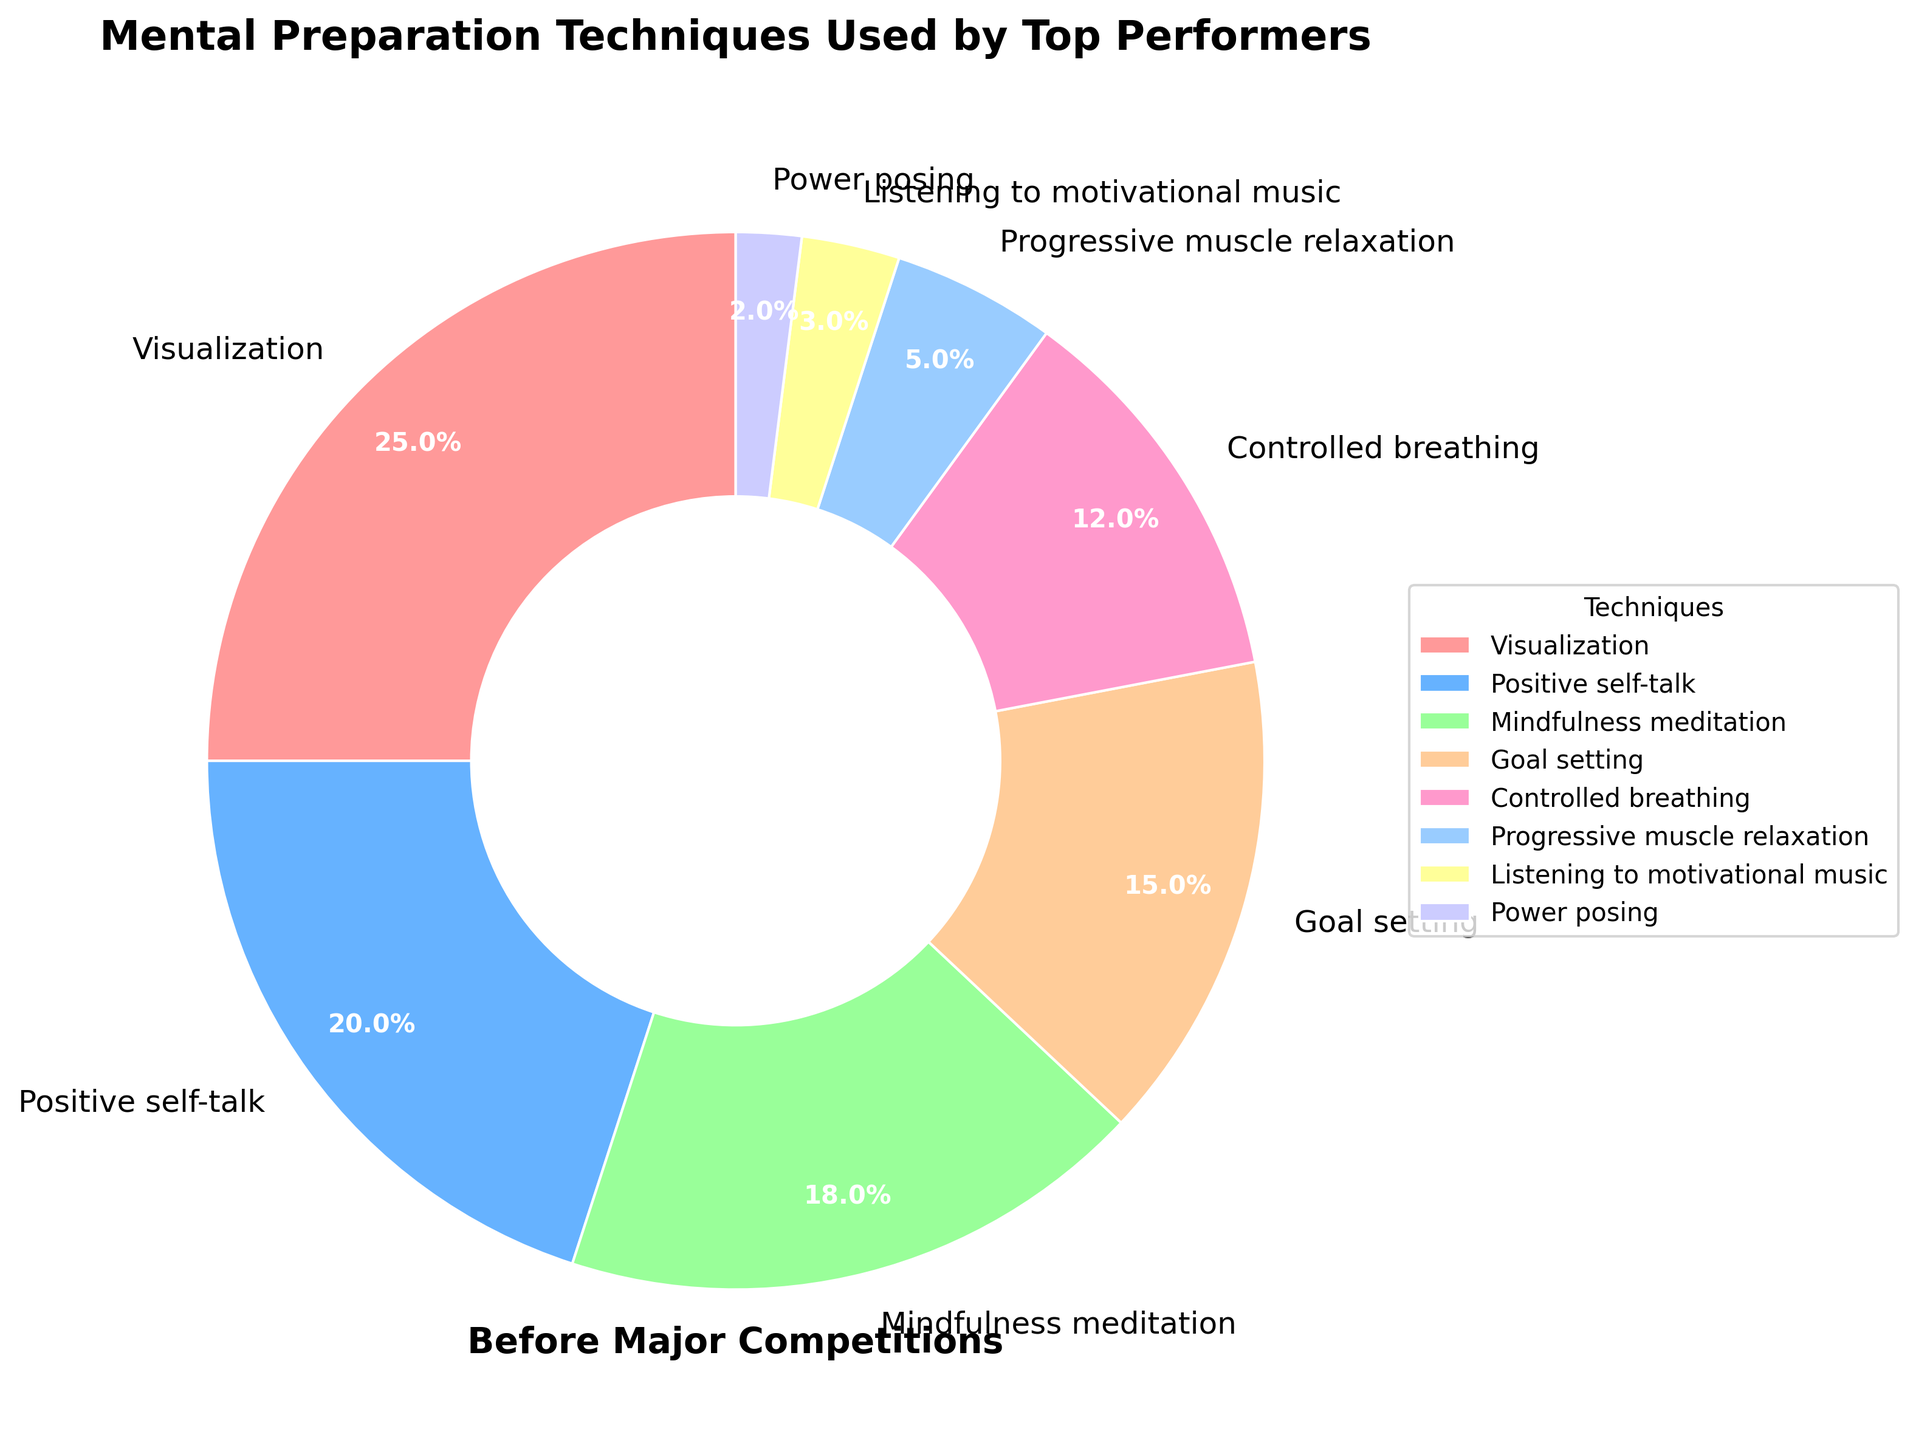What is the most commonly used mental preparation technique? The pie chart shows the percentages of different mental preparation techniques. The largest section of the chart represents "Visualization" with 25%. Therefore, "Visualization" is the most commonly used technique.
Answer: Visualization Which technique is more popular: Mindfulness meditation or Controlled breathing? The pie chart shows that "Mindfulness meditation" has a percentage of 18%, while "Controlled breathing" has a percentage of 12%. Therefore, "Mindfulness meditation" is more popular.
Answer: Mindfulness meditation What is the combined percentage of Positive self-talk and Goal setting? To find the combined percentage, add the percentages of "Positive self-talk" (20%) and "Goal setting" (15%): 20% + 15% = 35%.
Answer: 35% Which technique is least used by top performers? The smallest section in the pie chart represents "Power posing" with 2%. Therefore, "Power posing" is the least used technique by top performers.
Answer: Power posing How does the use of Listen to motivational music compare to Progressive muscle relaxation? According to the pie chart, "Listening to motivational music" has a percentage of 3%, while "Progressive muscle relaxation" has 5%. Hence, "Progressive muscle relaxation" is used more frequently than "Listening to motivational music".
Answer: Progressive muscle relaxation What fraction of the techniques have a percentage of 15% or higher? Techniques with percentages of 15% or higher are: "Visualization" (25%), "Positive self-talk" (20%), and "Goal setting" (15%). There are 8 techniques in total. Therefore, the fraction is 3/8.
Answer: 3/8 Is the percentage for Visualization greater than the combined percentage for Power posing and Listening to motivational music? The percentage for "Visualization" is 25%. The combined percentage for "Power posing" (2%) and "Listening to motivational music" (3%) is: 2% + 3% = 5%. Since 25% is greater than 5%, the percentage for "Visualization" is indeed greater.
Answer: Yes Are there any techniques that make up less than 5% of the chart? The pie chart shows that "Power posing" makes up 2% and "Listening to motivational music" makes up 3%. Both are less than 5%.
Answer: Yes What is the percentage difference between the most and least used techniques? The most used technique is "Visualization" with 25% and the least used technique is "Power posing" with 2%. The difference is: 25% - 2% = 23%.
Answer: 23% Which color represents Positive self-talk in the chart? In the pie chart, "Positive self-talk" is represented by a distinctive color which is usually labeled. Identify that section in the chart to Find the respective color. Typically, it may be shown as a color different from others, which should be clarified in the chart.
Answer: Check Chart 